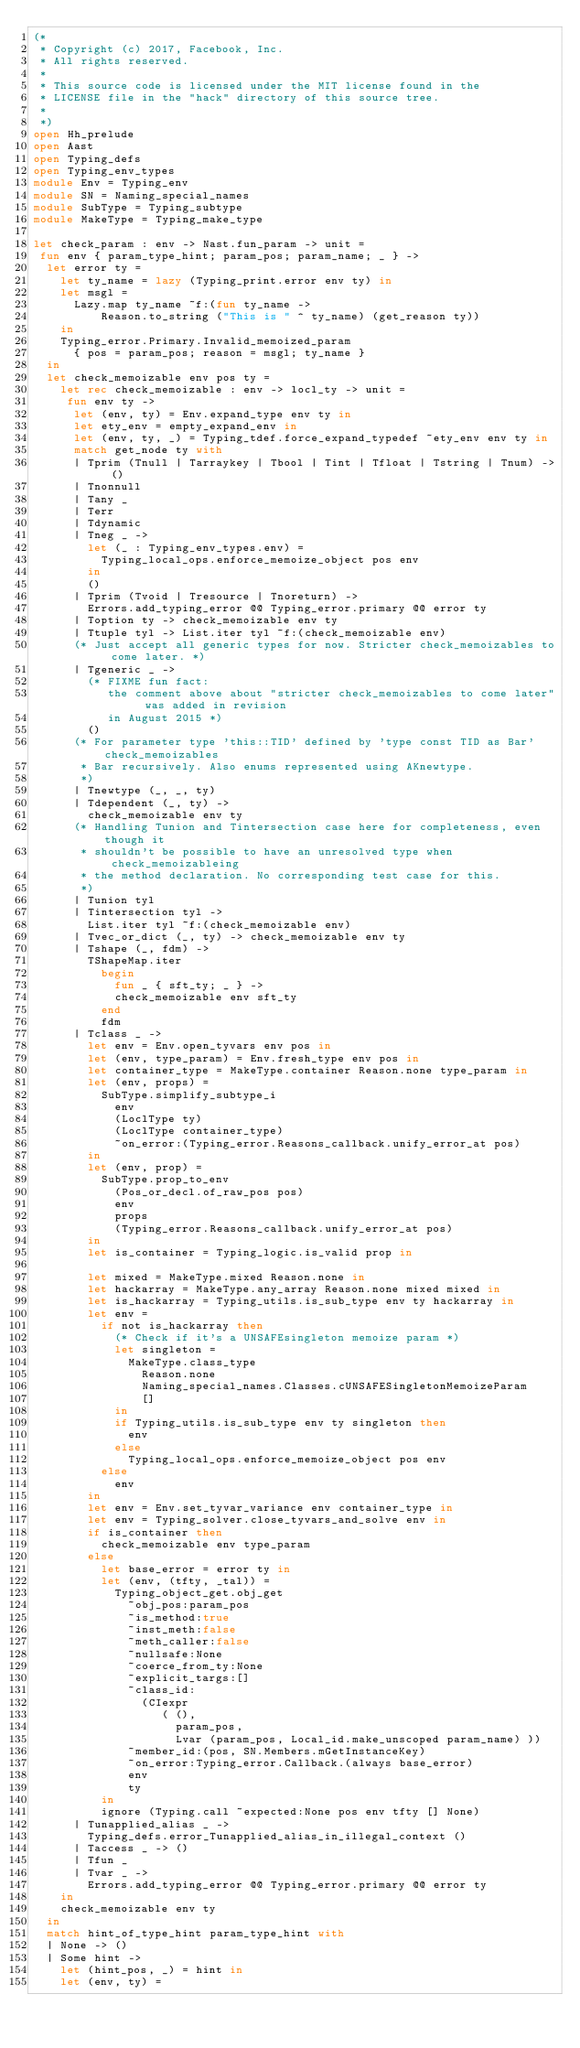<code> <loc_0><loc_0><loc_500><loc_500><_OCaml_>(*
 * Copyright (c) 2017, Facebook, Inc.
 * All rights reserved.
 *
 * This source code is licensed under the MIT license found in the
 * LICENSE file in the "hack" directory of this source tree.
 *
 *)
open Hh_prelude
open Aast
open Typing_defs
open Typing_env_types
module Env = Typing_env
module SN = Naming_special_names
module SubType = Typing_subtype
module MakeType = Typing_make_type

let check_param : env -> Nast.fun_param -> unit =
 fun env { param_type_hint; param_pos; param_name; _ } ->
  let error ty =
    let ty_name = lazy (Typing_print.error env ty) in
    let msgl =
      Lazy.map ty_name ~f:(fun ty_name ->
          Reason.to_string ("This is " ^ ty_name) (get_reason ty))
    in
    Typing_error.Primary.Invalid_memoized_param
      { pos = param_pos; reason = msgl; ty_name }
  in
  let check_memoizable env pos ty =
    let rec check_memoizable : env -> locl_ty -> unit =
     fun env ty ->
      let (env, ty) = Env.expand_type env ty in
      let ety_env = empty_expand_env in
      let (env, ty, _) = Typing_tdef.force_expand_typedef ~ety_env env ty in
      match get_node ty with
      | Tprim (Tnull | Tarraykey | Tbool | Tint | Tfloat | Tstring | Tnum) -> ()
      | Tnonnull
      | Tany _
      | Terr
      | Tdynamic
      | Tneg _ ->
        let (_ : Typing_env_types.env) =
          Typing_local_ops.enforce_memoize_object pos env
        in
        ()
      | Tprim (Tvoid | Tresource | Tnoreturn) ->
        Errors.add_typing_error @@ Typing_error.primary @@ error ty
      | Toption ty -> check_memoizable env ty
      | Ttuple tyl -> List.iter tyl ~f:(check_memoizable env)
      (* Just accept all generic types for now. Stricter check_memoizables to come later. *)
      | Tgeneric _ ->
        (* FIXME fun fact:
           the comment above about "stricter check_memoizables to come later" was added in revision
           in August 2015 *)
        ()
      (* For parameter type 'this::TID' defined by 'type const TID as Bar' check_memoizables
       * Bar recursively. Also enums represented using AKnewtype.
       *)
      | Tnewtype (_, _, ty)
      | Tdependent (_, ty) ->
        check_memoizable env ty
      (* Handling Tunion and Tintersection case here for completeness, even though it
       * shouldn't be possible to have an unresolved type when check_memoizableing
       * the method declaration. No corresponding test case for this.
       *)
      | Tunion tyl
      | Tintersection tyl ->
        List.iter tyl ~f:(check_memoizable env)
      | Tvec_or_dict (_, ty) -> check_memoizable env ty
      | Tshape (_, fdm) ->
        TShapeMap.iter
          begin
            fun _ { sft_ty; _ } ->
            check_memoizable env sft_ty
          end
          fdm
      | Tclass _ ->
        let env = Env.open_tyvars env pos in
        let (env, type_param) = Env.fresh_type env pos in
        let container_type = MakeType.container Reason.none type_param in
        let (env, props) =
          SubType.simplify_subtype_i
            env
            (LoclType ty)
            (LoclType container_type)
            ~on_error:(Typing_error.Reasons_callback.unify_error_at pos)
        in
        let (env, prop) =
          SubType.prop_to_env
            (Pos_or_decl.of_raw_pos pos)
            env
            props
            (Typing_error.Reasons_callback.unify_error_at pos)
        in
        let is_container = Typing_logic.is_valid prop in

        let mixed = MakeType.mixed Reason.none in
        let hackarray = MakeType.any_array Reason.none mixed mixed in
        let is_hackarray = Typing_utils.is_sub_type env ty hackarray in
        let env =
          if not is_hackarray then
            (* Check if it's a UNSAFEsingleton memoize param *)
            let singleton =
              MakeType.class_type
                Reason.none
                Naming_special_names.Classes.cUNSAFESingletonMemoizeParam
                []
            in
            if Typing_utils.is_sub_type env ty singleton then
              env
            else
              Typing_local_ops.enforce_memoize_object pos env
          else
            env
        in
        let env = Env.set_tyvar_variance env container_type in
        let env = Typing_solver.close_tyvars_and_solve env in
        if is_container then
          check_memoizable env type_param
        else
          let base_error = error ty in
          let (env, (tfty, _tal)) =
            Typing_object_get.obj_get
              ~obj_pos:param_pos
              ~is_method:true
              ~inst_meth:false
              ~meth_caller:false
              ~nullsafe:None
              ~coerce_from_ty:None
              ~explicit_targs:[]
              ~class_id:
                (CIexpr
                   ( (),
                     param_pos,
                     Lvar (param_pos, Local_id.make_unscoped param_name) ))
              ~member_id:(pos, SN.Members.mGetInstanceKey)
              ~on_error:Typing_error.Callback.(always base_error)
              env
              ty
          in
          ignore (Typing.call ~expected:None pos env tfty [] None)
      | Tunapplied_alias _ ->
        Typing_defs.error_Tunapplied_alias_in_illegal_context ()
      | Taccess _ -> ()
      | Tfun _
      | Tvar _ ->
        Errors.add_typing_error @@ Typing_error.primary @@ error ty
    in
    check_memoizable env ty
  in
  match hint_of_type_hint param_type_hint with
  | None -> ()
  | Some hint ->
    let (hint_pos, _) = hint in
    let (env, ty) =</code> 